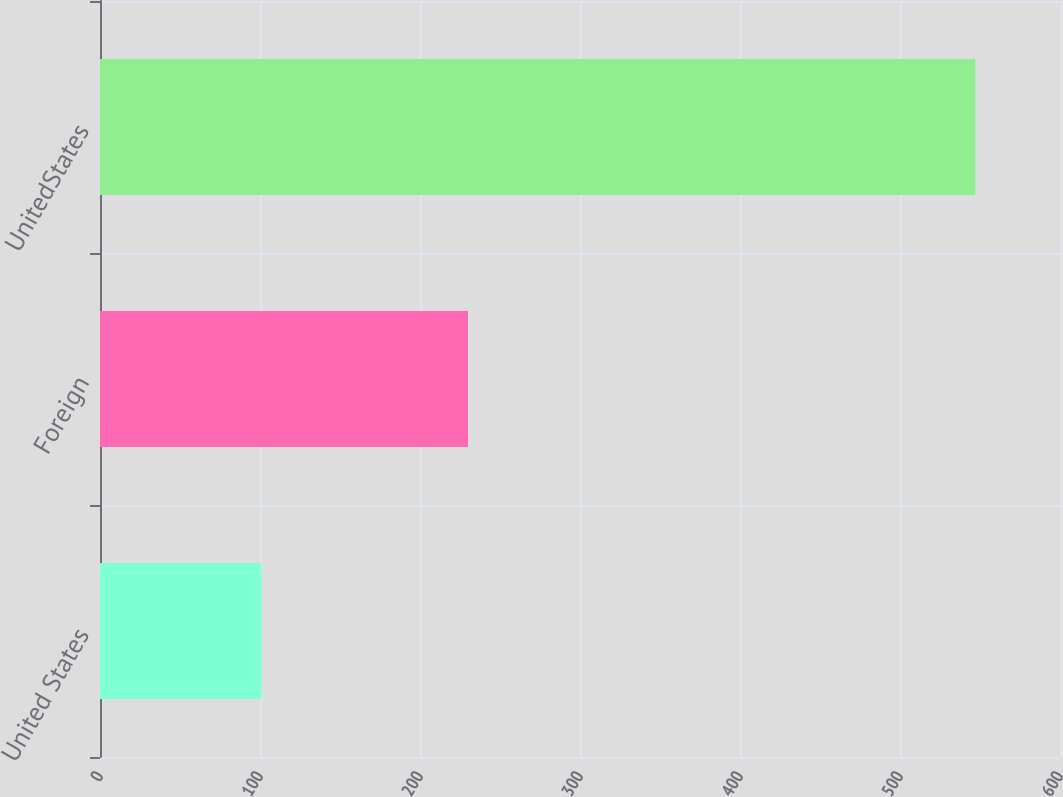<chart> <loc_0><loc_0><loc_500><loc_500><bar_chart><fcel>United States<fcel>Foreign<fcel>UnitedStates<nl><fcel>101<fcel>230<fcel>547<nl></chart> 